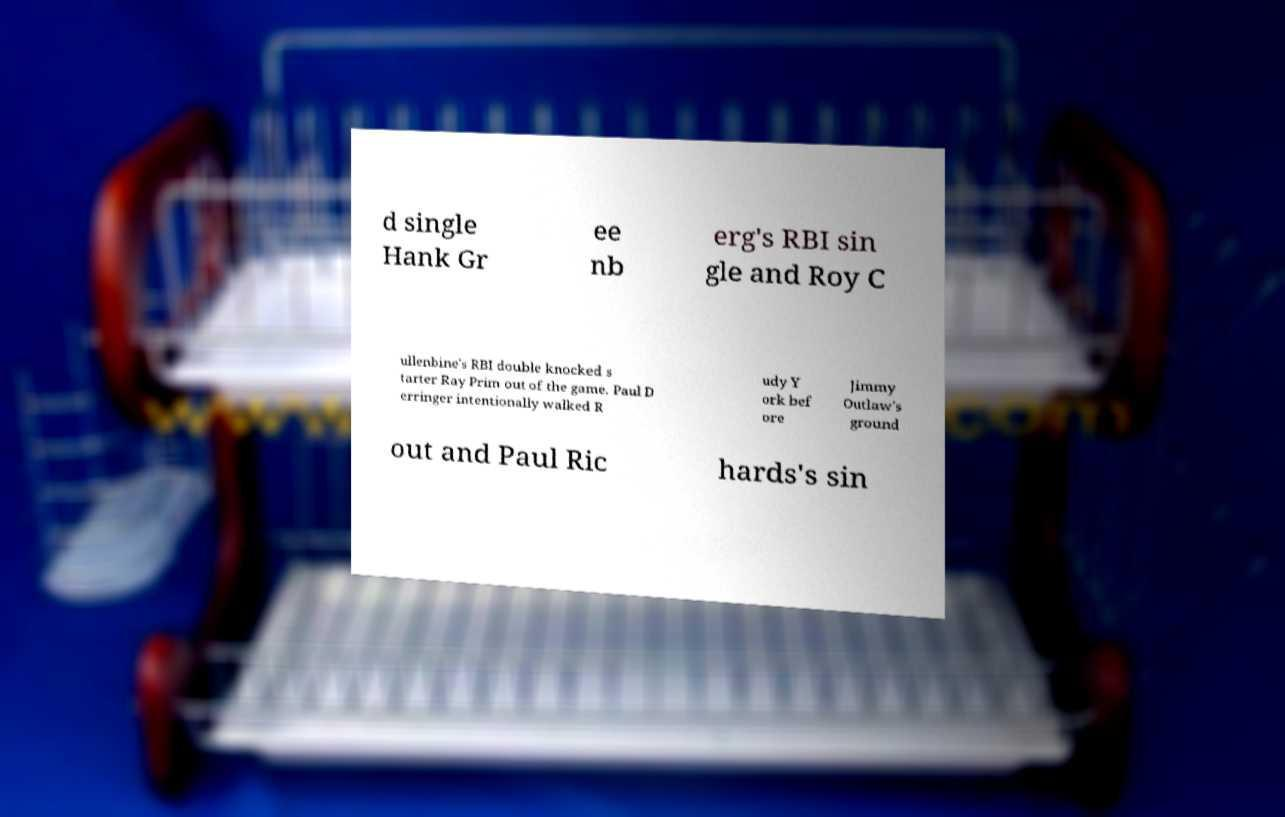Could you extract and type out the text from this image? d single Hank Gr ee nb erg's RBI sin gle and Roy C ullenbine's RBI double knocked s tarter Ray Prim out of the game. Paul D erringer intentionally walked R udy Y ork bef ore Jimmy Outlaw's ground out and Paul Ric hards's sin 